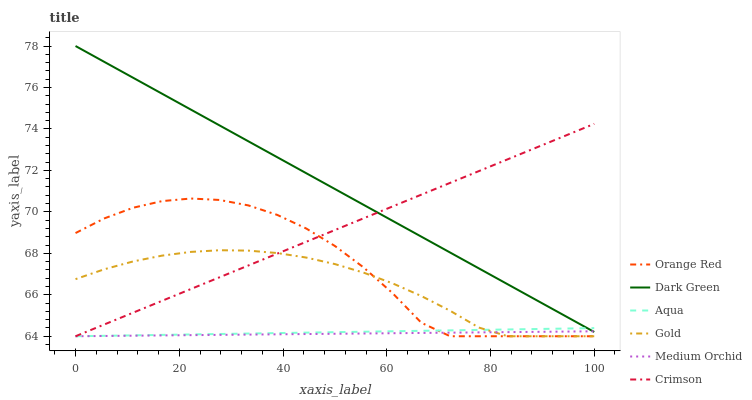Does Medium Orchid have the minimum area under the curve?
Answer yes or no. Yes. Does Dark Green have the maximum area under the curve?
Answer yes or no. Yes. Does Aqua have the minimum area under the curve?
Answer yes or no. No. Does Aqua have the maximum area under the curve?
Answer yes or no. No. Is Aqua the smoothest?
Answer yes or no. Yes. Is Orange Red the roughest?
Answer yes or no. Yes. Is Medium Orchid the smoothest?
Answer yes or no. No. Is Medium Orchid the roughest?
Answer yes or no. No. Does Gold have the lowest value?
Answer yes or no. Yes. Does Dark Green have the lowest value?
Answer yes or no. No. Does Dark Green have the highest value?
Answer yes or no. Yes. Does Aqua have the highest value?
Answer yes or no. No. Is Orange Red less than Dark Green?
Answer yes or no. Yes. Is Dark Green greater than Gold?
Answer yes or no. Yes. Does Aqua intersect Orange Red?
Answer yes or no. Yes. Is Aqua less than Orange Red?
Answer yes or no. No. Is Aqua greater than Orange Red?
Answer yes or no. No. Does Orange Red intersect Dark Green?
Answer yes or no. No. 